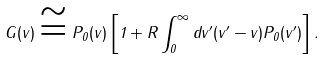Convert formula to latex. <formula><loc_0><loc_0><loc_500><loc_500>G ( v ) \cong P _ { 0 } ( v ) \left [ 1 + R \int _ { 0 } ^ { \infty } d v ^ { \prime } ( v ^ { \prime } - v ) P _ { 0 } ( v ^ { \prime } ) \right ] .</formula> 